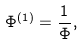Convert formula to latex. <formula><loc_0><loc_0><loc_500><loc_500>\Phi ^ { ( 1 ) } = \frac { 1 } { \Phi } ,</formula> 